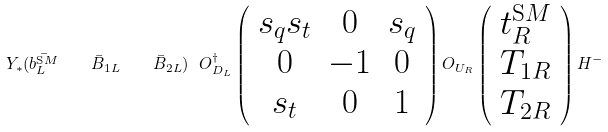Convert formula to latex. <formula><loc_0><loc_0><loc_500><loc_500>Y _ { * } ( \bar { b ^ { \text  SM}_{L}} \quad \bar{B}_{1L} \quad \bar{B}_{2L})\ O_{D_{L}}^{\dagger} \left( \begin{array}{ccc} s_{q} s_{t} & 0 & s_{q} \\ 0 & -1 & 0 \\ s_{t} & 0 & 1 \end{array} \right) O_{U_{R}} \left( \begin{array}{c} t^{\text  SM}_{R} \\ T_{1R} \\ T_{2R} \end{array} \right) H^{-}</formula> 